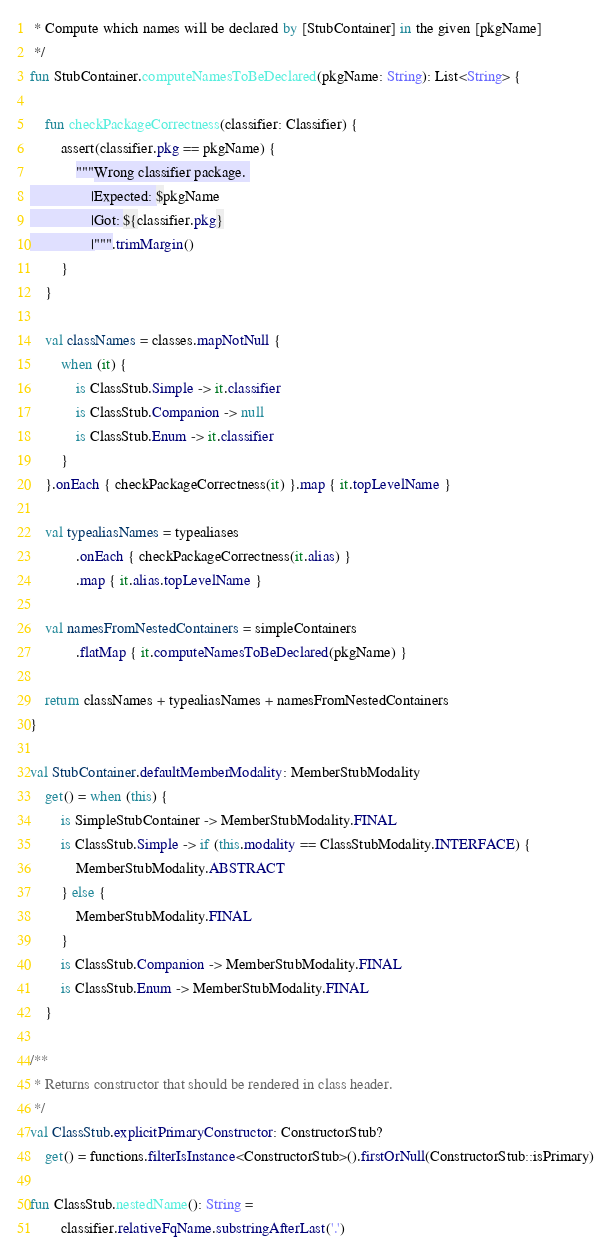Convert code to text. <code><loc_0><loc_0><loc_500><loc_500><_Kotlin_> * Compute which names will be declared by [StubContainer] in the given [pkgName]
 */
fun StubContainer.computeNamesToBeDeclared(pkgName: String): List<String> {

    fun checkPackageCorrectness(classifier: Classifier) {
        assert(classifier.pkg == pkgName) {
            """Wrong classifier package. 
                |Expected: $pkgName
                |Got: ${classifier.pkg}
                |""".trimMargin()
        }
    }

    val classNames = classes.mapNotNull {
        when (it) {
            is ClassStub.Simple -> it.classifier
            is ClassStub.Companion -> null
            is ClassStub.Enum -> it.classifier
        }
    }.onEach { checkPackageCorrectness(it) }.map { it.topLevelName }

    val typealiasNames = typealiases
            .onEach { checkPackageCorrectness(it.alias) }
            .map { it.alias.topLevelName }

    val namesFromNestedContainers = simpleContainers
            .flatMap { it.computeNamesToBeDeclared(pkgName) }

    return classNames + typealiasNames + namesFromNestedContainers
}

val StubContainer.defaultMemberModality: MemberStubModality
    get() = when (this) {
        is SimpleStubContainer -> MemberStubModality.FINAL
        is ClassStub.Simple -> if (this.modality == ClassStubModality.INTERFACE) {
            MemberStubModality.ABSTRACT
        } else {
            MemberStubModality.FINAL
        }
        is ClassStub.Companion -> MemberStubModality.FINAL
        is ClassStub.Enum -> MemberStubModality.FINAL
    }

/**
 * Returns constructor that should be rendered in class header.
 */
val ClassStub.explicitPrimaryConstructor: ConstructorStub?
    get() = functions.filterIsInstance<ConstructorStub>().firstOrNull(ConstructorStub::isPrimary)

fun ClassStub.nestedName(): String =
        classifier.relativeFqName.substringAfterLast('.')</code> 